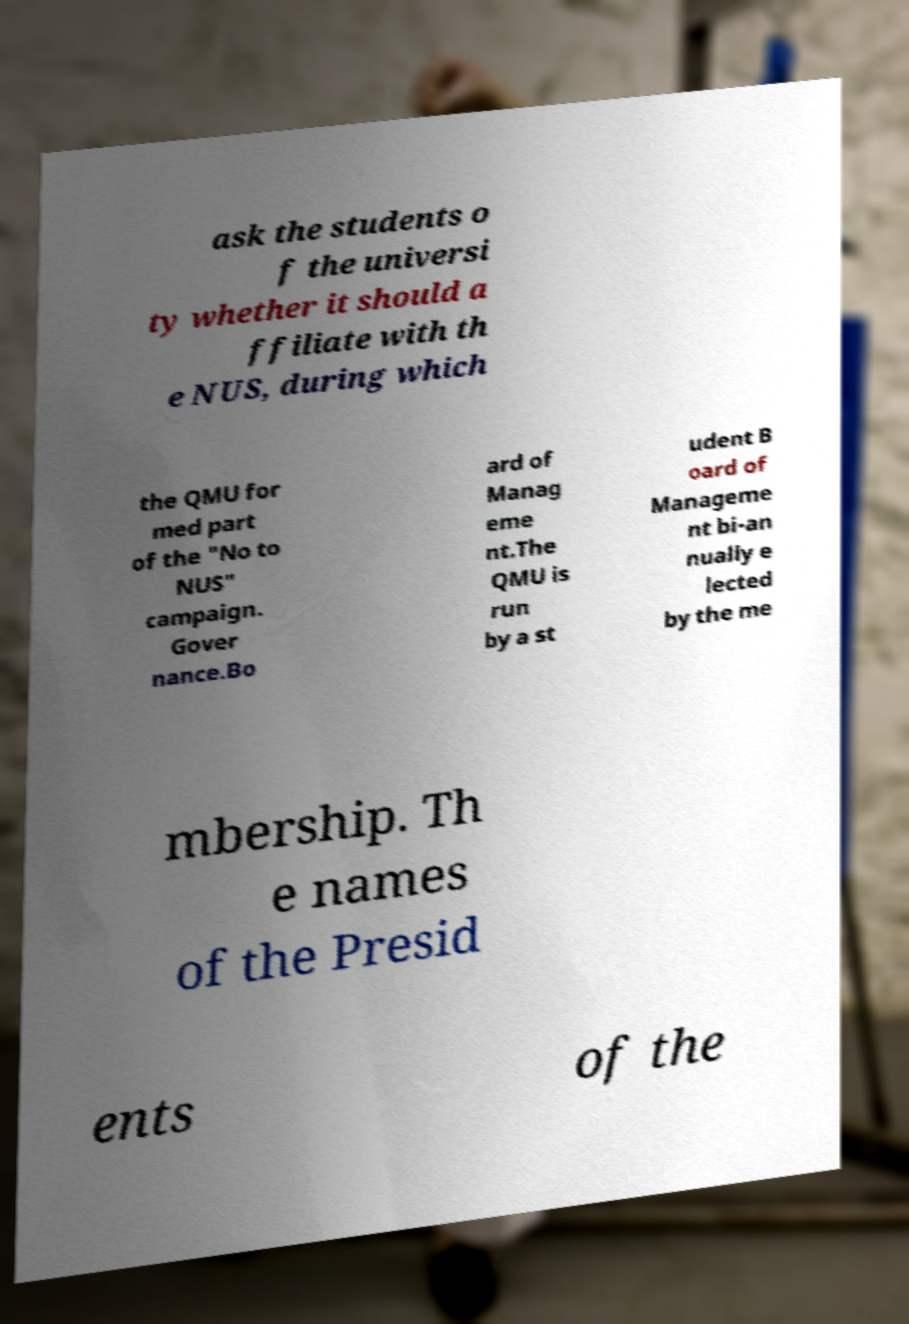Can you accurately transcribe the text from the provided image for me? ask the students o f the universi ty whether it should a ffiliate with th e NUS, during which the QMU for med part of the "No to NUS" campaign. Gover nance.Bo ard of Manag eme nt.The QMU is run by a st udent B oard of Manageme nt bi-an nually e lected by the me mbership. Th e names of the Presid ents of the 